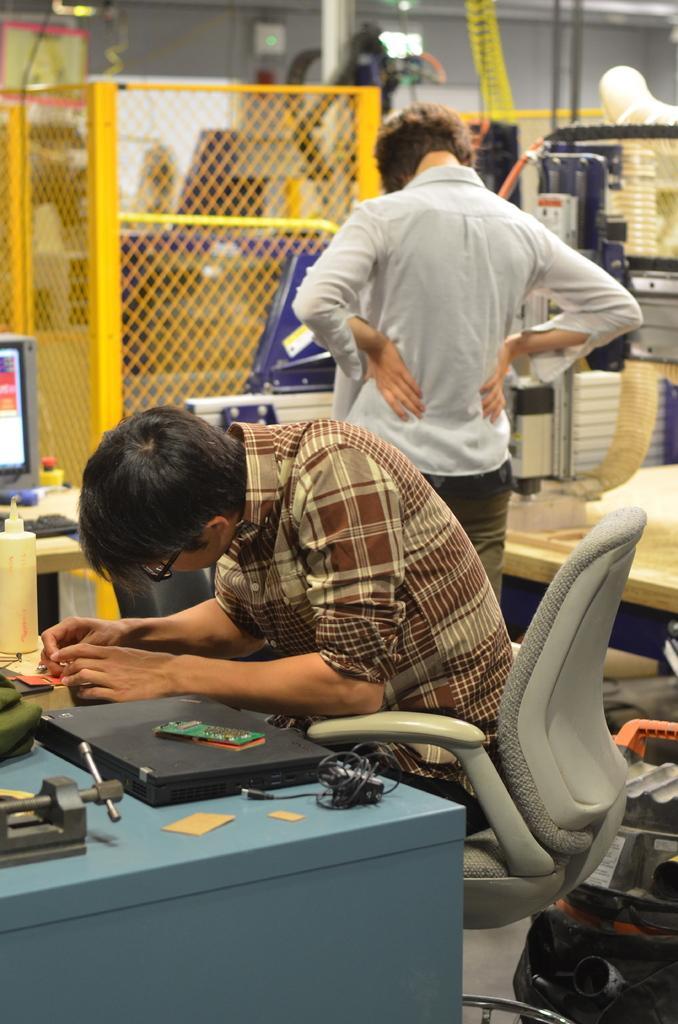In one or two sentences, can you explain what this image depicts? This is a picture of a man sitting in a chair a table where we have laptop,cable,papers and the back ground we have a man , computer in table and some grills ,and some pipes. 